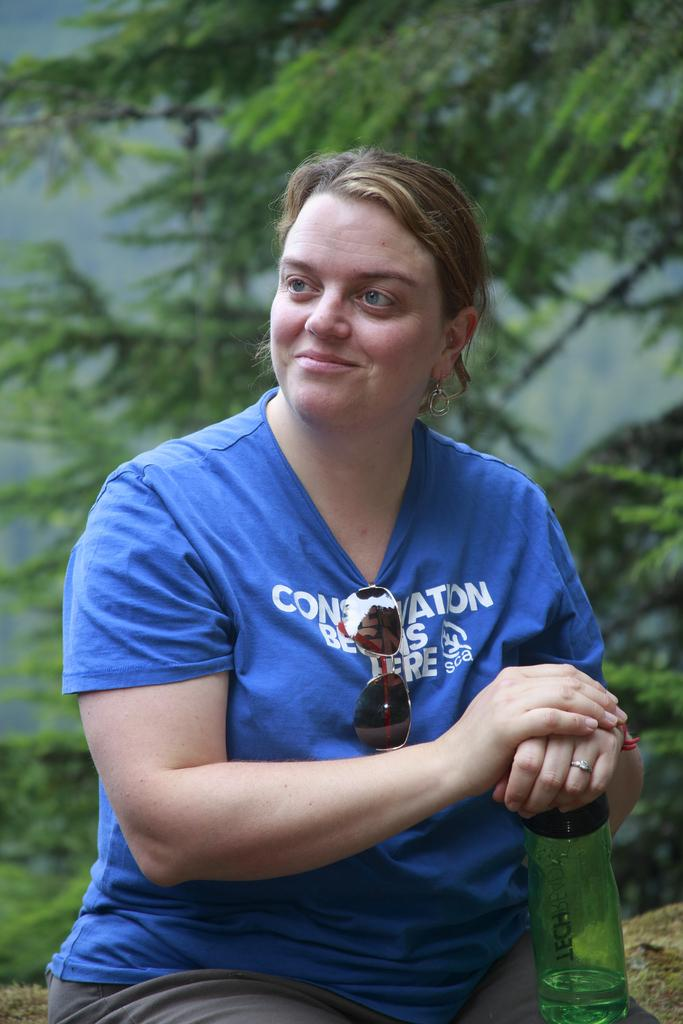Who is in the image? There is a woman in the image. What is the woman doing in the image? The woman is seated and smiling. What is the woman holding in the image? The woman is holding a water bottle. What can be seen in the background of the image? There is a tree visible in the background of the image. How many minutes does it take for the tramp to complete a full cycle in the image? There is no tramp present in the image, so it is not possible to determine how many minutes it would take for a tramp to complete a full cycle. 